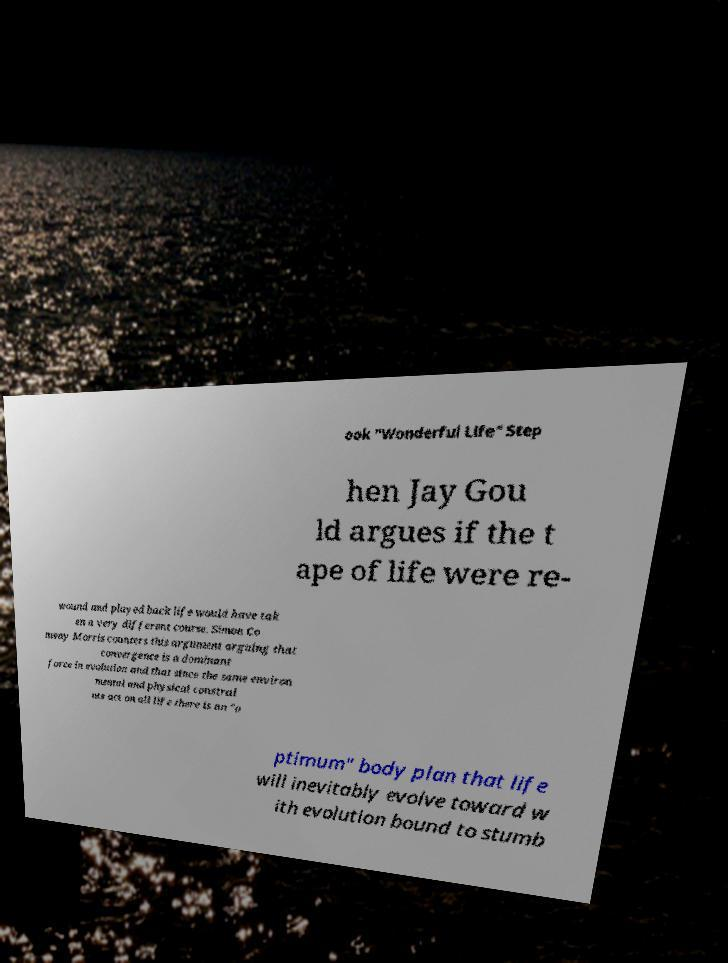There's text embedded in this image that I need extracted. Can you transcribe it verbatim? ook "Wonderful Life" Step hen Jay Gou ld argues if the t ape of life were re- wound and played back life would have tak en a very different course. Simon Co nway Morris counters this argument arguing that convergence is a dominant force in evolution and that since the same environ mental and physical constrai nts act on all life there is an "o ptimum" body plan that life will inevitably evolve toward w ith evolution bound to stumb 